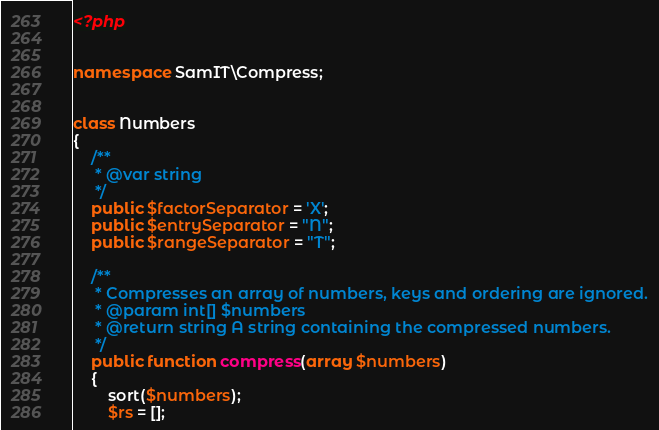<code> <loc_0><loc_0><loc_500><loc_500><_PHP_><?php


namespace SamIT\Compress;


class Numbers
{
    /**
     * @var string
     */
    public $factorSeparator = 'X';
    public $entrySeparator = "N";
    public $rangeSeparator = "T";

    /**
     * Compresses an array of numbers, keys and ordering are ignored.
     * @param int[] $numbers
     * @return string A string containing the compressed numbers.
     */
    public function compress(array $numbers)
    {
        sort($numbers);
        $rs = [];</code> 